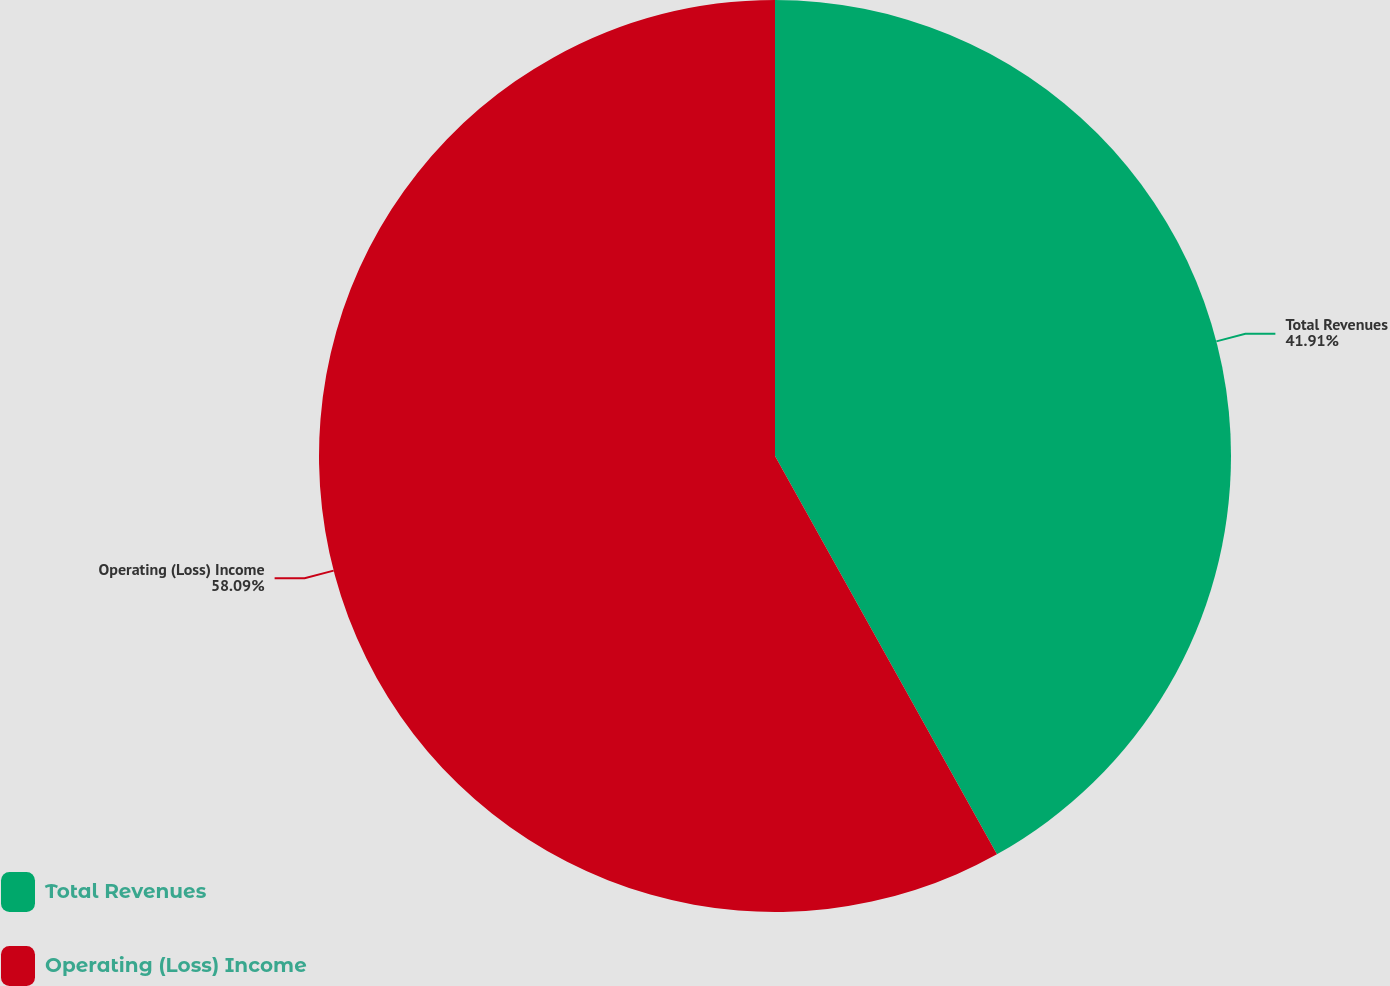Convert chart. <chart><loc_0><loc_0><loc_500><loc_500><pie_chart><fcel>Total Revenues<fcel>Operating (Loss) Income<nl><fcel>41.91%<fcel>58.09%<nl></chart> 